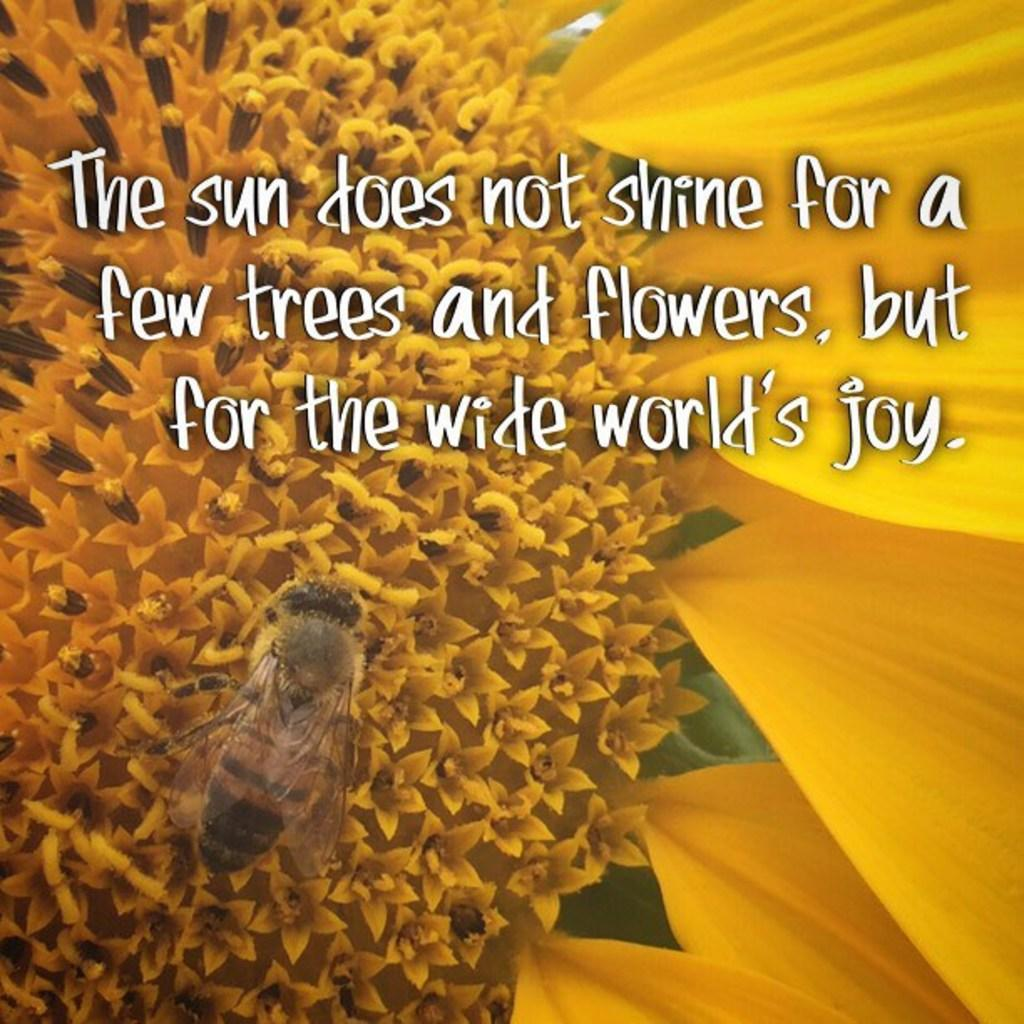What is the main subject of the image? The main subject of the image is many flowers. Are there any other living creatures in the image besides the flowers? Yes, there is an insect in the image. Is there any text present in the image? Yes, there is some text in the image. What type of game is being played in the image? There is no game present in the image; it features many flowers and an insect. 